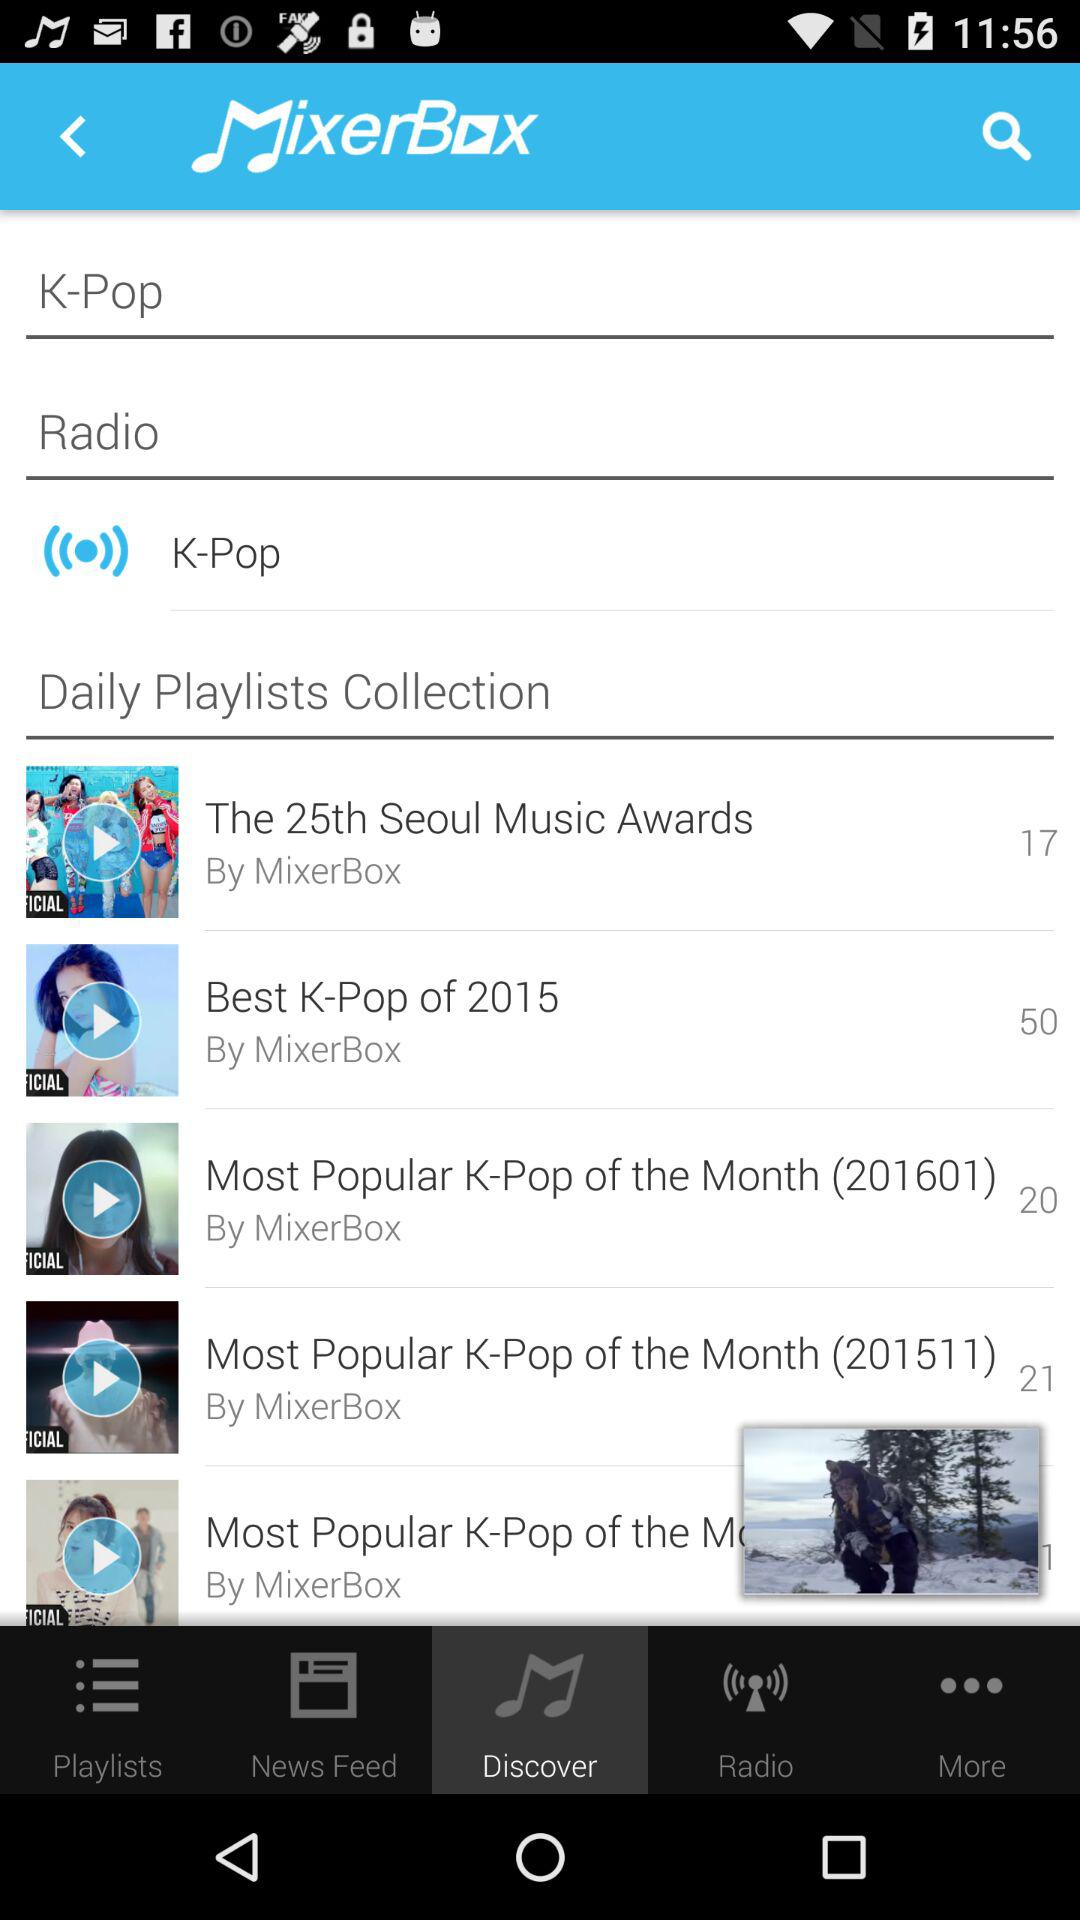What is the name of the creator who created the "Best K-Pop of 2015" playlist? The name of the creator is "MixerBox". 